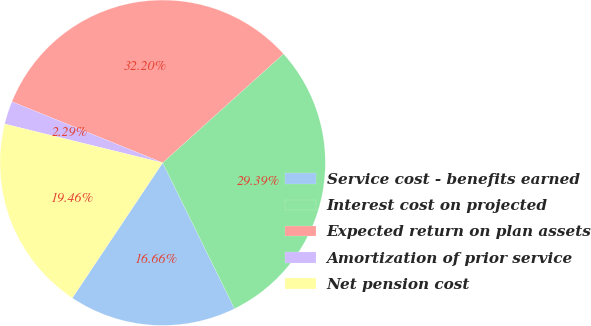Convert chart. <chart><loc_0><loc_0><loc_500><loc_500><pie_chart><fcel>Service cost - benefits earned<fcel>Interest cost on projected<fcel>Expected return on plan assets<fcel>Amortization of prior service<fcel>Net pension cost<nl><fcel>16.66%<fcel>29.39%<fcel>32.2%<fcel>2.29%<fcel>19.46%<nl></chart> 